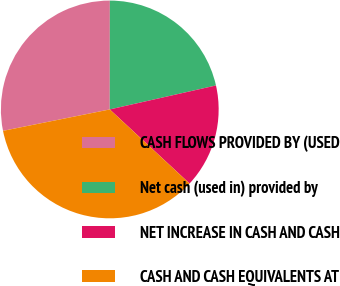<chart> <loc_0><loc_0><loc_500><loc_500><pie_chart><fcel>CASH FLOWS PROVIDED BY (USED<fcel>Net cash (used in) provided by<fcel>NET INCREASE IN CASH AND CASH<fcel>CASH AND CASH EQUIVALENTS AT<nl><fcel>28.16%<fcel>21.45%<fcel>15.44%<fcel>34.94%<nl></chart> 